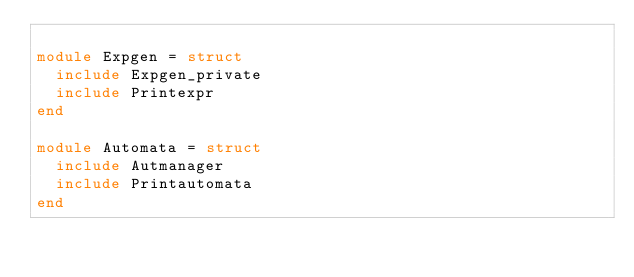Convert code to text. <code><loc_0><loc_0><loc_500><loc_500><_OCaml_>
module Expgen = struct
  include Expgen_private
  include Printexpr
end

module Automata = struct
  include Autmanager
  include Printautomata
end
</code> 